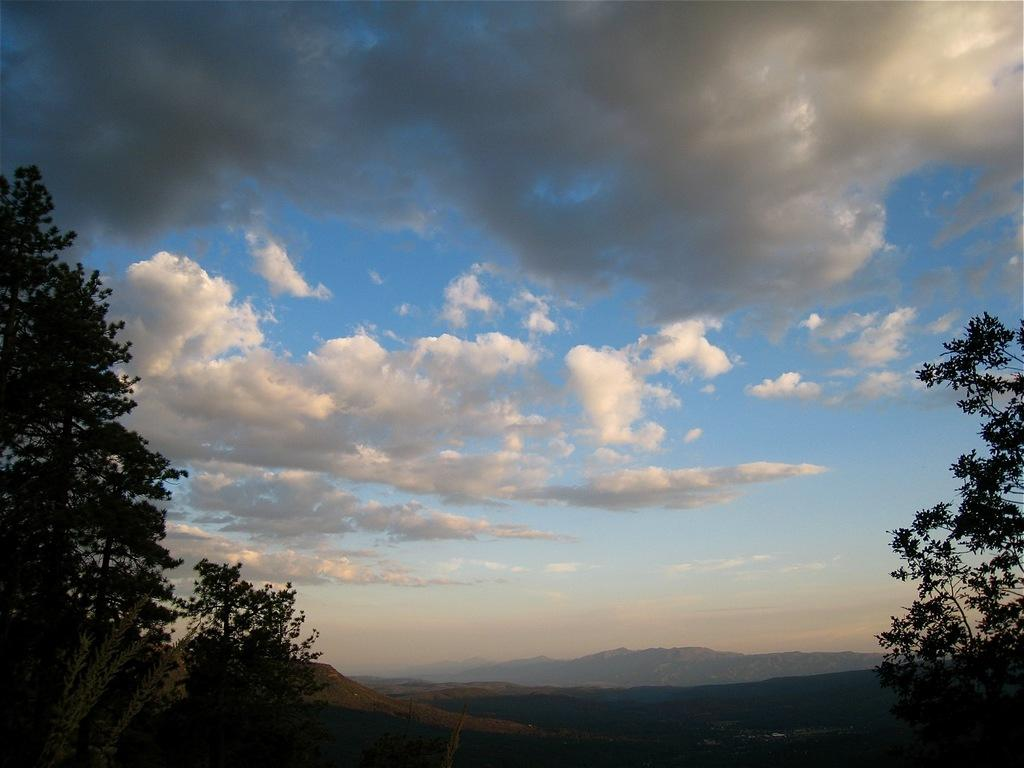What can be seen in the sky in the image? The sky is visible in the image, and there are clouds in the sky. What type of natural features can be seen in the background of the image? There are mountains in the background of the image. What type of vegetation is present in the image? Trees and plants are visible in the image. What type of whistle can be heard coming from the mountains in the image? There is no whistle present in the image, and no sound can be heard from the mountains. 